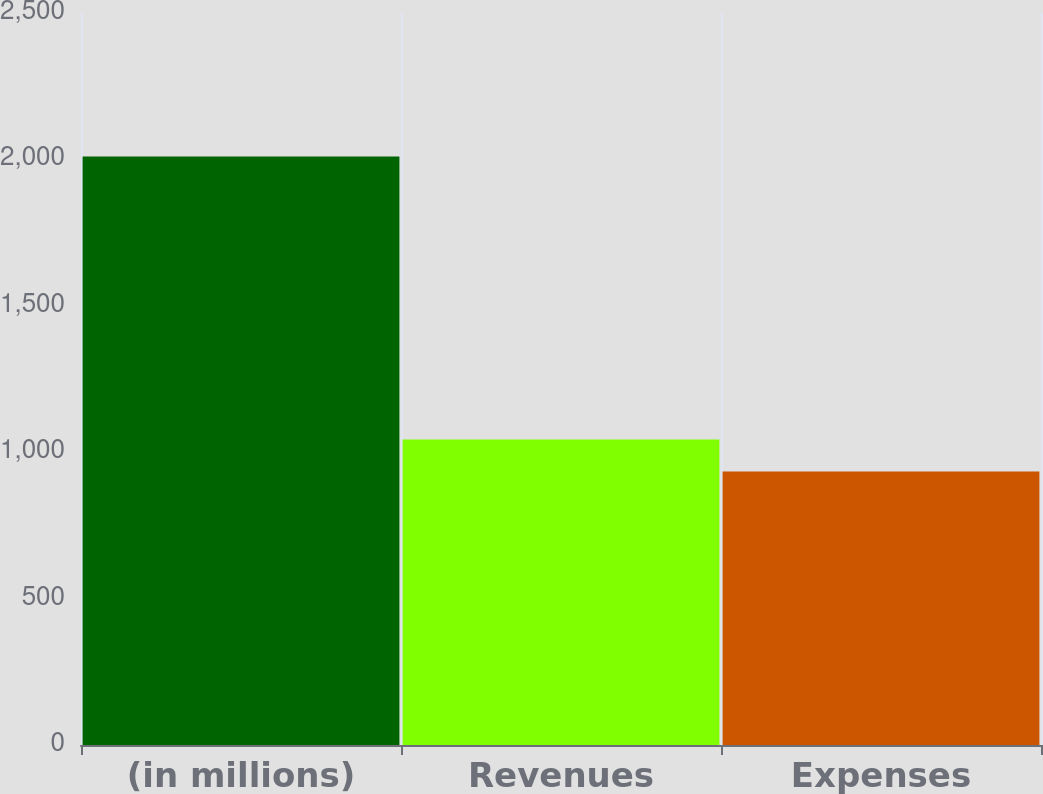Convert chart to OTSL. <chart><loc_0><loc_0><loc_500><loc_500><bar_chart><fcel>(in millions)<fcel>Revenues<fcel>Expenses<nl><fcel>2010<fcel>1043<fcel>934<nl></chart> 